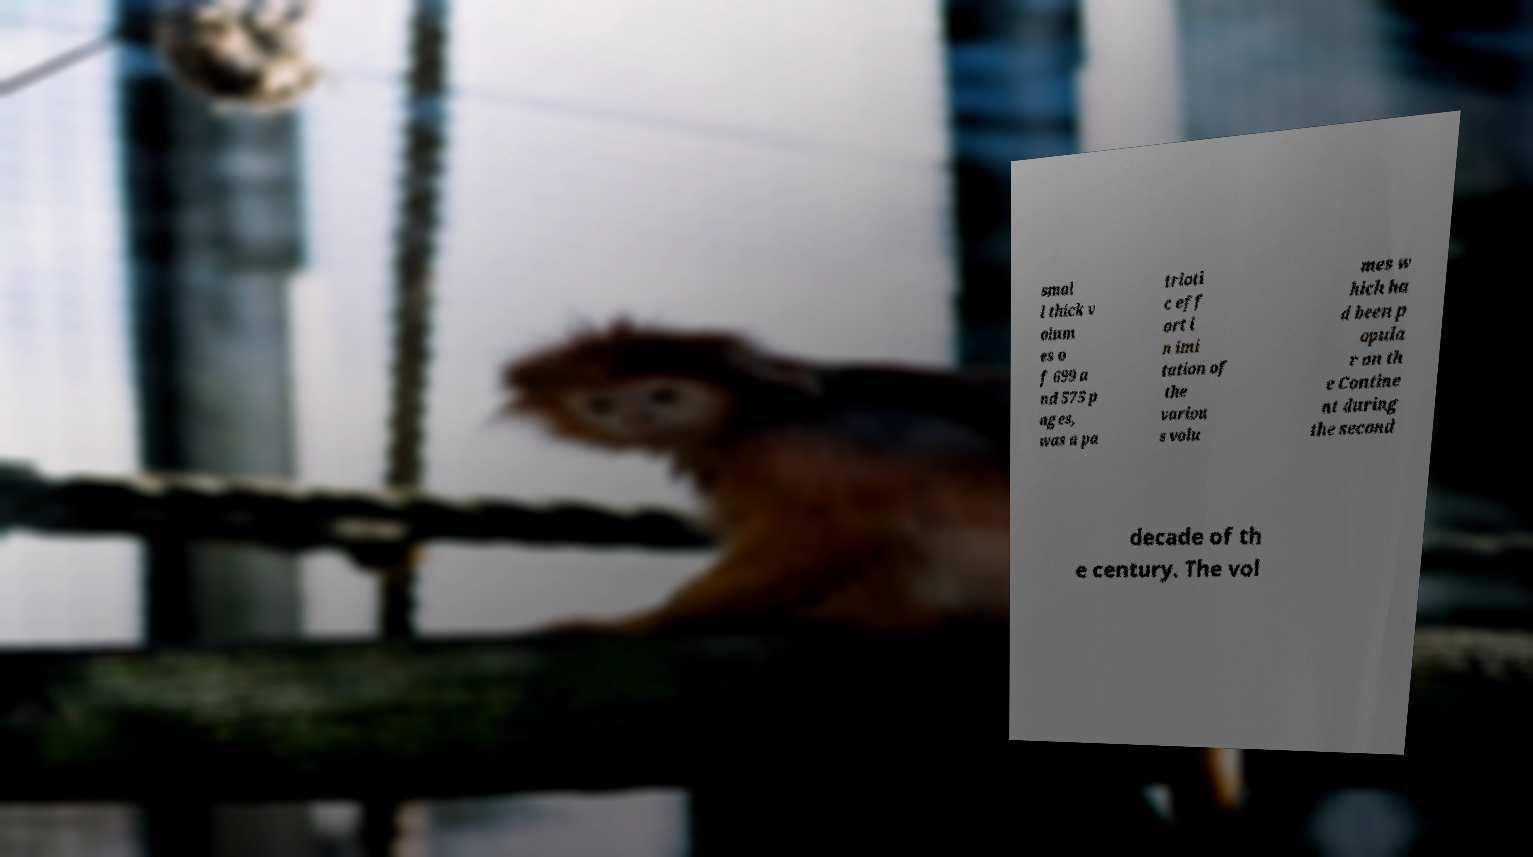Please read and relay the text visible in this image. What does it say? smal l thick v olum es o f 699 a nd 575 p ages, was a pa trioti c eff ort i n imi tation of the variou s volu mes w hich ha d been p opula r on th e Contine nt during the second decade of th e century. The vol 